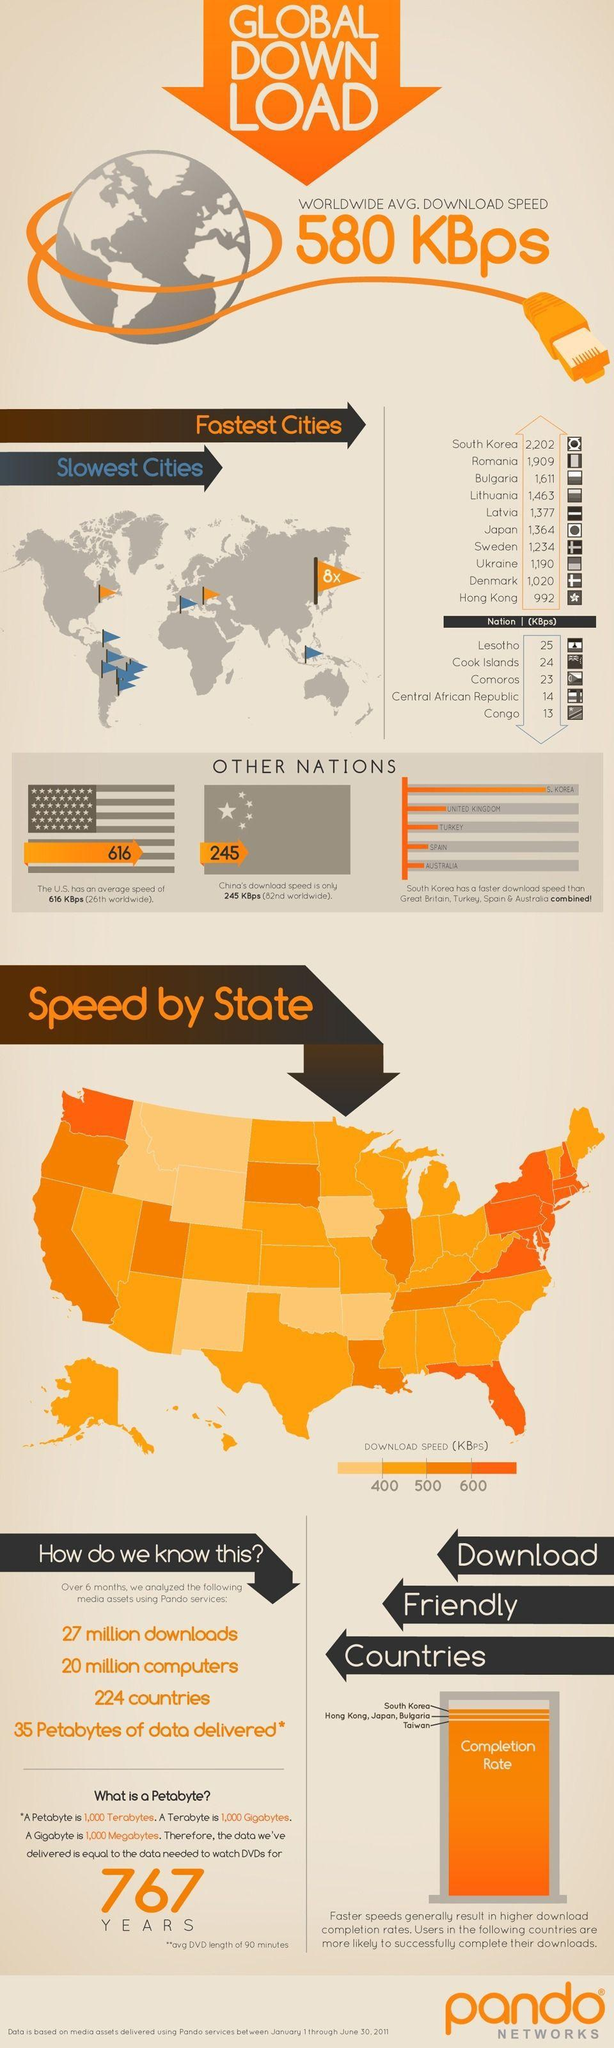Draw attention to some important aspects in this diagram. South Korea has eight times faster internet speeds than the rest of the world, making it the country with the fastest internet in the world. The Central African Republic and the Democratic Republic of the Congo have internet speeds of less than 15 kilobits per second. It is estimated that there are 7 states in the US that have lower-than-400 KBps download speed. 